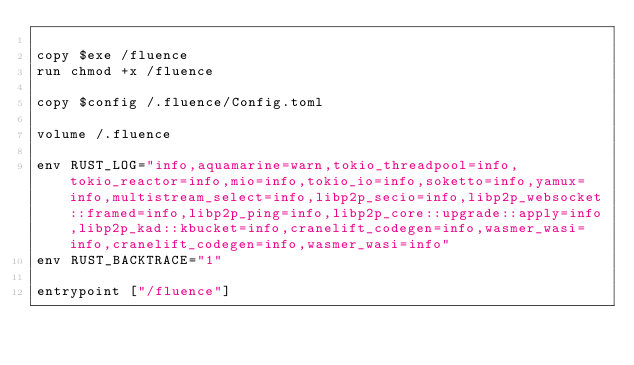Convert code to text. <code><loc_0><loc_0><loc_500><loc_500><_Dockerfile_>
copy $exe /fluence
run chmod +x /fluence

copy $config /.fluence/Config.toml

volume /.fluence

env RUST_LOG="info,aquamarine=warn,tokio_threadpool=info,tokio_reactor=info,mio=info,tokio_io=info,soketto=info,yamux=info,multistream_select=info,libp2p_secio=info,libp2p_websocket::framed=info,libp2p_ping=info,libp2p_core::upgrade::apply=info,libp2p_kad::kbucket=info,cranelift_codegen=info,wasmer_wasi=info,cranelift_codegen=info,wasmer_wasi=info"
env RUST_BACKTRACE="1"

entrypoint ["/fluence"]
</code> 